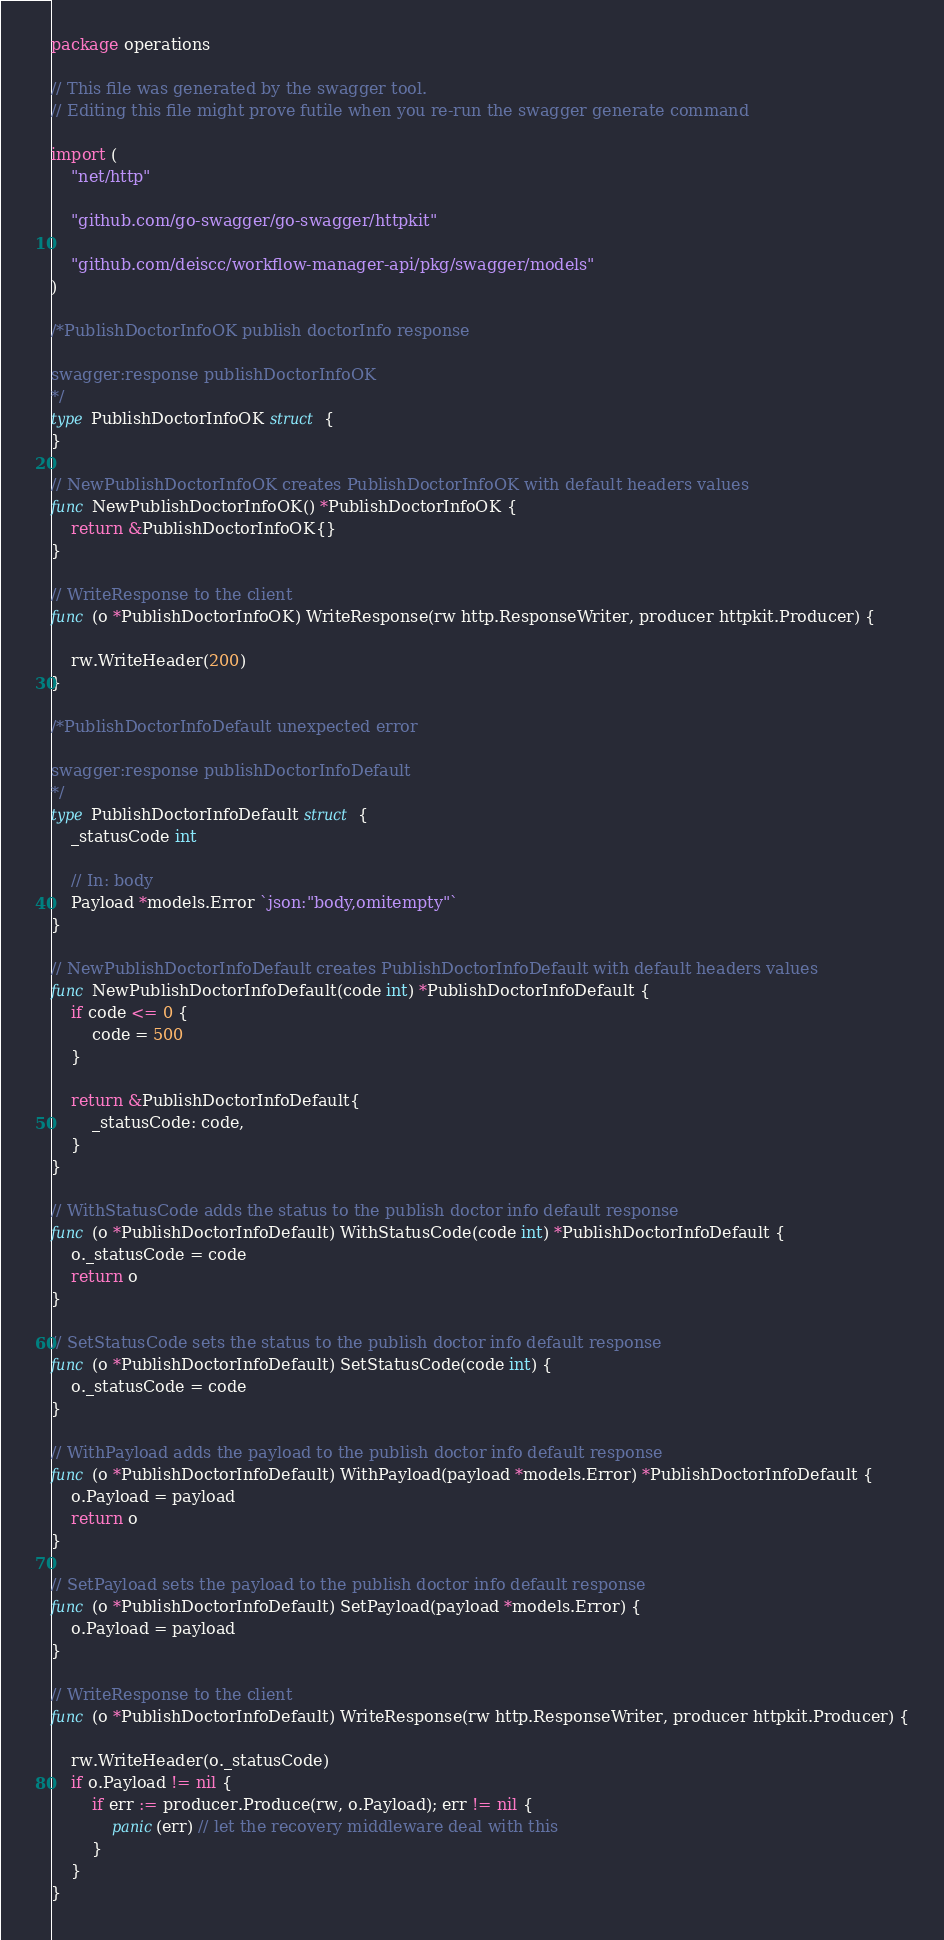<code> <loc_0><loc_0><loc_500><loc_500><_Go_>package operations

// This file was generated by the swagger tool.
// Editing this file might prove futile when you re-run the swagger generate command

import (
	"net/http"

	"github.com/go-swagger/go-swagger/httpkit"

	"github.com/deiscc/workflow-manager-api/pkg/swagger/models"
)

/*PublishDoctorInfoOK publish doctorInfo response

swagger:response publishDoctorInfoOK
*/
type PublishDoctorInfoOK struct {
}

// NewPublishDoctorInfoOK creates PublishDoctorInfoOK with default headers values
func NewPublishDoctorInfoOK() *PublishDoctorInfoOK {
	return &PublishDoctorInfoOK{}
}

// WriteResponse to the client
func (o *PublishDoctorInfoOK) WriteResponse(rw http.ResponseWriter, producer httpkit.Producer) {

	rw.WriteHeader(200)
}

/*PublishDoctorInfoDefault unexpected error

swagger:response publishDoctorInfoDefault
*/
type PublishDoctorInfoDefault struct {
	_statusCode int

	// In: body
	Payload *models.Error `json:"body,omitempty"`
}

// NewPublishDoctorInfoDefault creates PublishDoctorInfoDefault with default headers values
func NewPublishDoctorInfoDefault(code int) *PublishDoctorInfoDefault {
	if code <= 0 {
		code = 500
	}

	return &PublishDoctorInfoDefault{
		_statusCode: code,
	}
}

// WithStatusCode adds the status to the publish doctor info default response
func (o *PublishDoctorInfoDefault) WithStatusCode(code int) *PublishDoctorInfoDefault {
	o._statusCode = code
	return o
}

// SetStatusCode sets the status to the publish doctor info default response
func (o *PublishDoctorInfoDefault) SetStatusCode(code int) {
	o._statusCode = code
}

// WithPayload adds the payload to the publish doctor info default response
func (o *PublishDoctorInfoDefault) WithPayload(payload *models.Error) *PublishDoctorInfoDefault {
	o.Payload = payload
	return o
}

// SetPayload sets the payload to the publish doctor info default response
func (o *PublishDoctorInfoDefault) SetPayload(payload *models.Error) {
	o.Payload = payload
}

// WriteResponse to the client
func (o *PublishDoctorInfoDefault) WriteResponse(rw http.ResponseWriter, producer httpkit.Producer) {

	rw.WriteHeader(o._statusCode)
	if o.Payload != nil {
		if err := producer.Produce(rw, o.Payload); err != nil {
			panic(err) // let the recovery middleware deal with this
		}
	}
}
</code> 